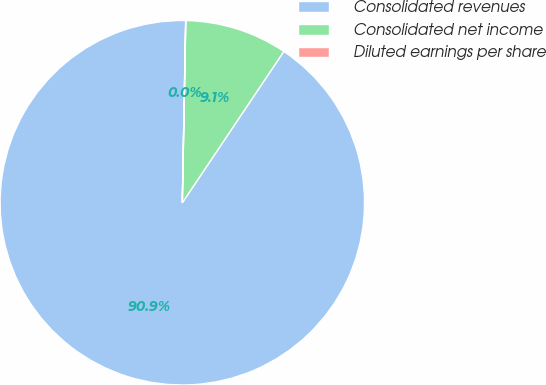Convert chart to OTSL. <chart><loc_0><loc_0><loc_500><loc_500><pie_chart><fcel>Consolidated revenues<fcel>Consolidated net income<fcel>Diluted earnings per share<nl><fcel>90.89%<fcel>9.1%<fcel>0.01%<nl></chart> 